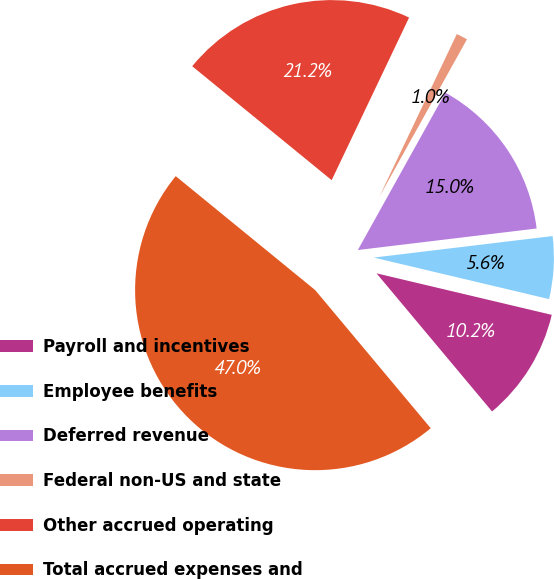Convert chart to OTSL. <chart><loc_0><loc_0><loc_500><loc_500><pie_chart><fcel>Payroll and incentives<fcel>Employee benefits<fcel>Deferred revenue<fcel>Federal non-US and state<fcel>Other accrued operating<fcel>Total accrued expenses and<nl><fcel>10.21%<fcel>5.61%<fcel>15.01%<fcel>1.01%<fcel>21.17%<fcel>46.99%<nl></chart> 